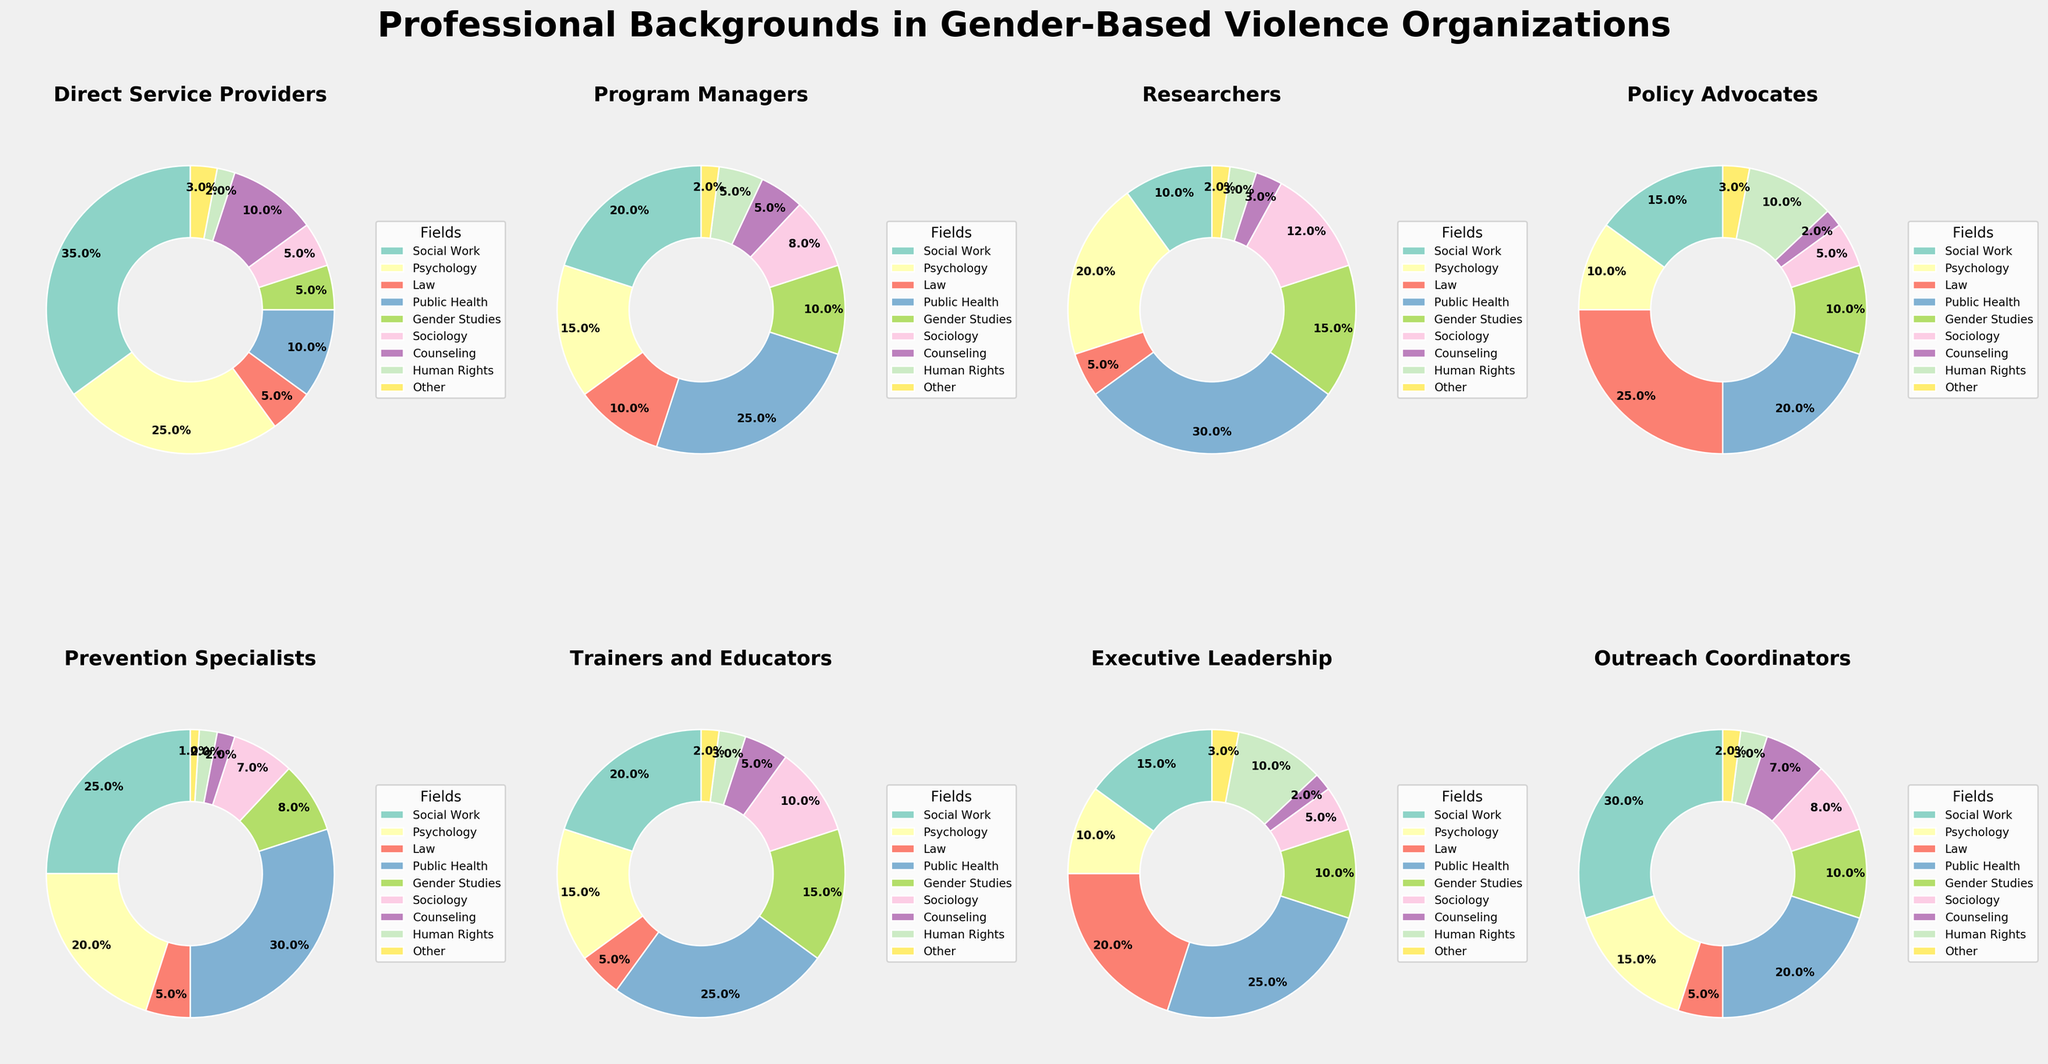What's the largest professional background for Direct Service Providers? The pie chart for Direct Service Providers shows that the largest segment is labeled Social Work, which covers the largest area.
Answer: Social Work How does the proportion of individuals with a Public Health background compare between Program Managers and Researchers? The pie chart for Program Managers shows that 25% have a Public Health background, while the pie chart for Researchers shows 30%.
Answer: Researchers have a higher proportion Which two professional backgrounds are least represented among Researchers? The pie chart for Researchers shows the smallest segments for Human Rights and Other, each contributing equally small portions.
Answer: Human Rights, Other What is the combined percentage of Staff with Psychology or Counseling backgrounds among Trainers and Educators? In the pie chart for Trainers and Educators, Psychology is 15% and Counseling is 5%. Adding these together, 15% + 5% = 20%.
Answer: 20% For Policy Advocates, which professional background makes up exactly twice the percentage of Human Rights? According to the pie chart for Policy Advocates, Human Rights is 10%. The professional background with exactly double this percentage is Law, which is 25%.
Answer: Law What is the most common professional background among Prevention Specialists? The pie chart for Prevention Specialists shows Public Health as the largest segment.
Answer: Public Health Which professional background has the same proportion in Executive Leadership as in Outreach Coordinators? The pie charts for both Executive Leadership and Outreach Coordinators show that Other is 3% in both categories.
Answer: Other Is the proportion of Sociology backgrounds higher in Researchers or Executive Leadership? According to their pie charts, the Researchers have 12% in Sociology, while Executive Leadership has 5%. Therefore, Researchers have a higher proportion.
Answer: Researchers Which category has the smallest percentage of staff with a Gender Studies background? Comparing the pie charts, Direct Service Providers and Researchers both have 5% for Gender Studies, which is the smallest.
Answer: Direct Service Providers, Researchers What's the difference in percentage points between Staff with a Social Work background in Outreach Coordinators and Executive Leadership? The pie chart for Outreach Coordinators shows 30% in Social Work, while Executive Leadership shows 15%. The difference is 30% - 15% = 15%.
Answer: 15% 